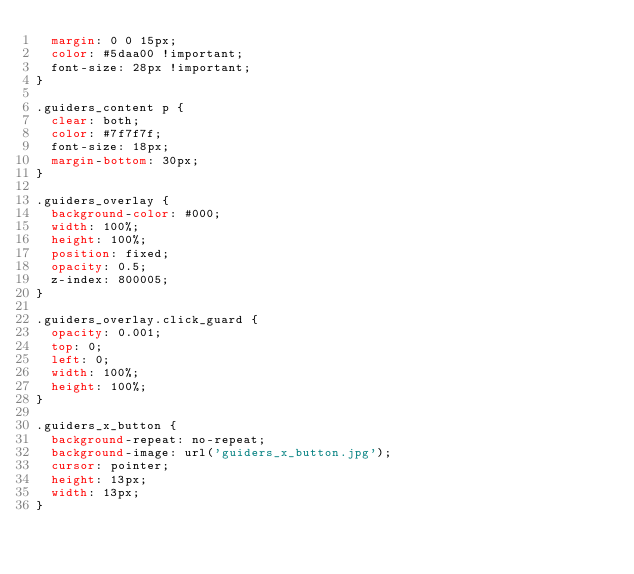<code> <loc_0><loc_0><loc_500><loc_500><_CSS_>  margin: 0 0 15px;
  color: #5daa00 !important;
  font-size: 28px !important;
}

.guiders_content p {
  clear: both;
  color: #7f7f7f;
  font-size: 18px;
  margin-bottom: 30px;
}

.guiders_overlay {
  background-color: #000;
  width: 100%;
  height: 100%;
  position: fixed;
  opacity: 0.5;
  z-index: 800005;
}

.guiders_overlay.click_guard {
  opacity: 0.001;
  top: 0;
  left: 0;
  width: 100%;
  height: 100%;
}

.guiders_x_button {
  background-repeat: no-repeat;
  background-image: url('guiders_x_button.jpg');
  cursor: pointer;
  height: 13px;
  width: 13px;
}
</code> 